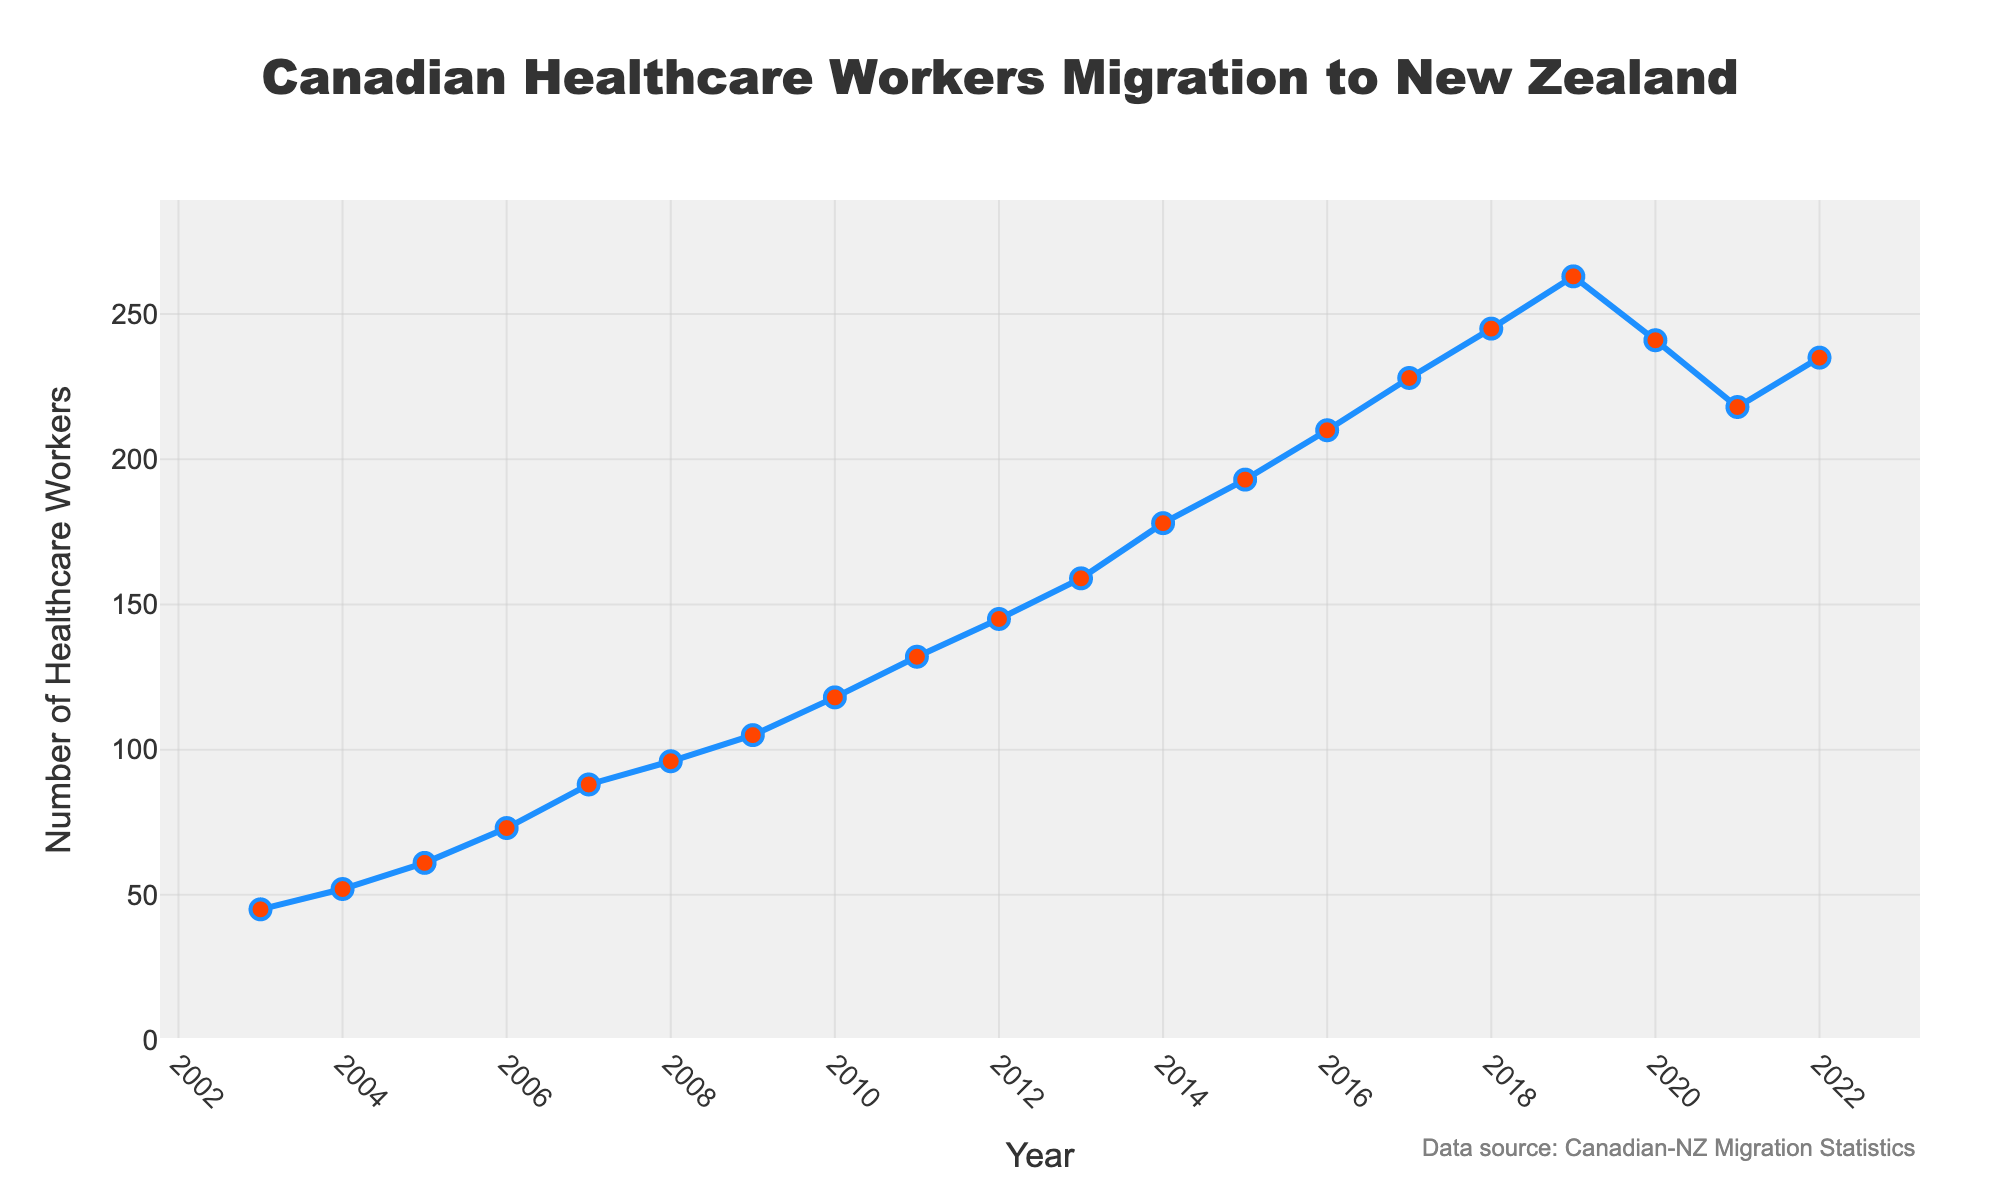What is the general trend of Canadian healthcare workers migrating to New Zealand from 2003 to 2022? The general trend shows a steady increase in the number of Canadian healthcare workers migrating to New Zealand. While there is an overall upward trend, there are slight declines in 2020 and 2021.
Answer: Steady increase What was the highest number of Canadian healthcare workers migrating to New Zealand in any year shown, and in which year did this occur? The highest number of Canadian healthcare workers migrating to New Zealand was 263, and it occurred in 2019.
Answer: 263 in 2019 How did the number of migrating healthcare workers in 2008 compare with that in 2018? In 2008, the number of migrating healthcare workers was 96, while in 2018, it was 245. Therefore, the number of migrating workers in 2018 was significantly higher than in 2008.
Answer: 245 in 2018 was higher than 96 in 2008 What was the difference in the number of healthcare workers migrating between 2020 and 2021? In 2020, 241 healthcare workers migrated, and in 2021, 218 migrated. The difference is 241 - 218 = 23.
Answer: 23 Between which consecutive years was there the sharpest increase in the number of migrating healthcare workers? The sharpest increase occurred between 2018 and 2019, where the number increased from 245 to 263, a difference of 263 - 245 = 18.
Answer: Between 2018 and 2019 What is the average number of healthcare workers migrating per year from 2010 to 2020? Sum the numbers from 2010 to 2020, which are 118, 132, 145, 159, 178, 193, 210, 228, 245, 263, and 241, then divide by 11 (years). The sum is 2112, so the average is 2112/11 ≈ 192.
Answer: Approximately 192 What visual feature indicates a decline in migration trends, and where is it observed? The line dips, indicating a decline in migration trends, observed between the years 2019-2020 and 2020-2021.
Answer: Line dips between 2019-2020 and 2020-2021 What can be said about the migration trends in the initial and final 5 years (2003-2007 vs. 2018-2022)? In the initial 5 years (2003-2007), the migration increased from 45 to 88 (43 more), while in the final 5 years (2018-2022), it increased from 245 to 235 (10 less, though with fluctuations). The initial period shows steady increases, while the final period shows more fluctuation with a slight net decrease.
Answer: Initial period: steady increase, final period: fluctuation with slight net decrease 